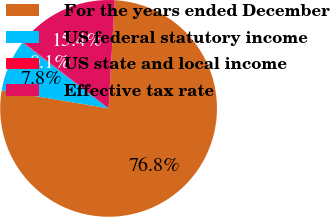Convert chart. <chart><loc_0><loc_0><loc_500><loc_500><pie_chart><fcel>For the years ended December<fcel>US federal statutory income<fcel>US state and local income<fcel>Effective tax rate<nl><fcel>76.75%<fcel>7.75%<fcel>0.08%<fcel>15.42%<nl></chart> 